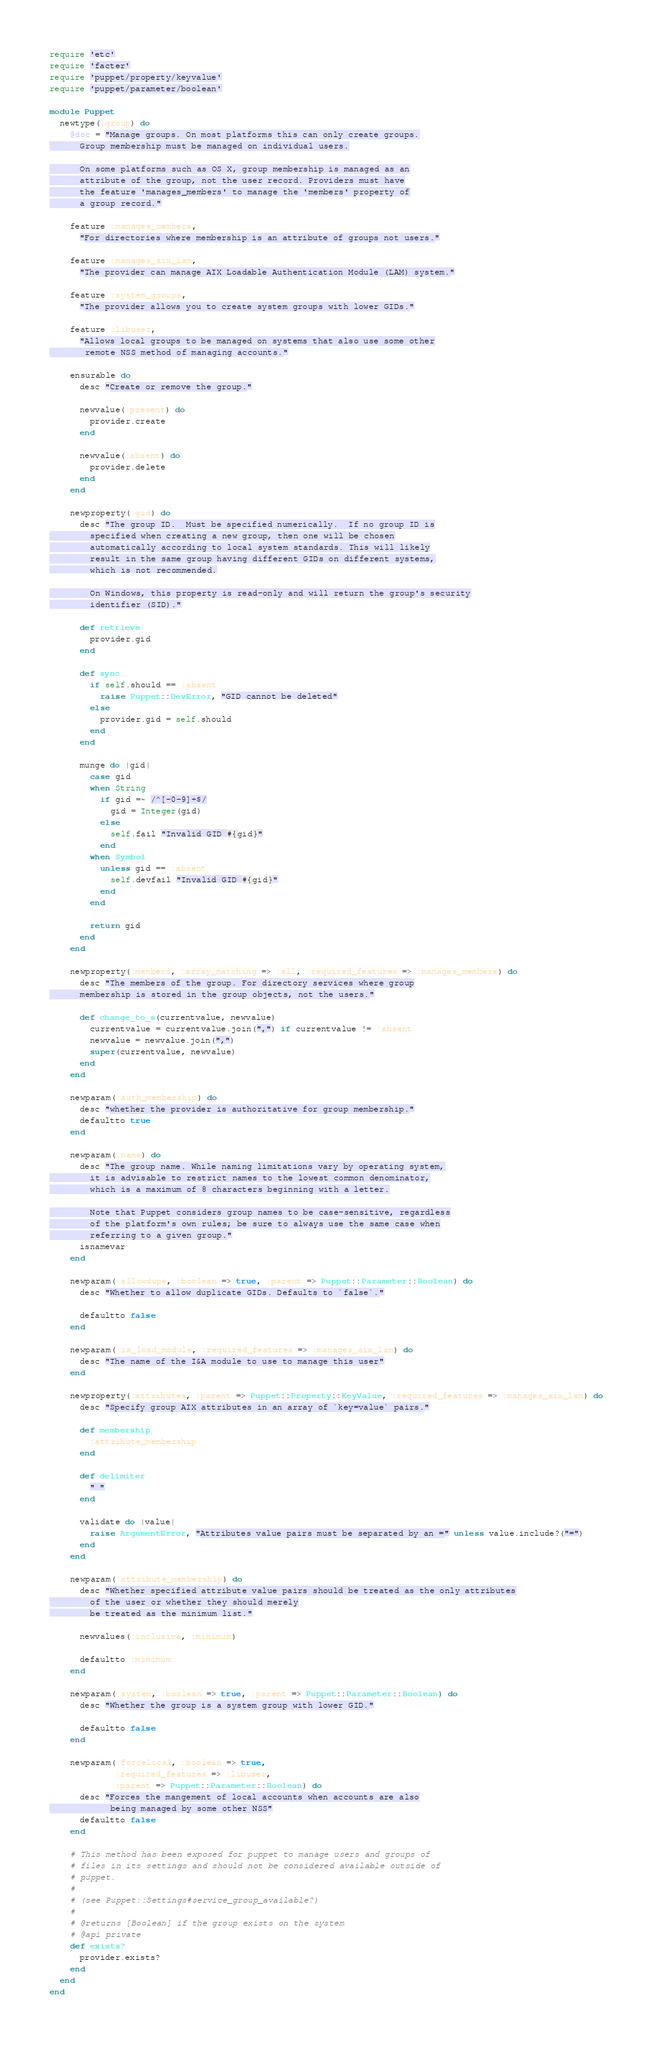Convert code to text. <code><loc_0><loc_0><loc_500><loc_500><_Ruby_>require 'etc'
require 'facter'
require 'puppet/property/keyvalue'
require 'puppet/parameter/boolean'

module Puppet
  newtype(:group) do
    @doc = "Manage groups. On most platforms this can only create groups.
      Group membership must be managed on individual users.

      On some platforms such as OS X, group membership is managed as an
      attribute of the group, not the user record. Providers must have
      the feature 'manages_members' to manage the 'members' property of
      a group record."

    feature :manages_members,
      "For directories where membership is an attribute of groups not users."

    feature :manages_aix_lam,
      "The provider can manage AIX Loadable Authentication Module (LAM) system."

    feature :system_groups,
      "The provider allows you to create system groups with lower GIDs."

    feature :libuser,
      "Allows local groups to be managed on systems that also use some other
       remote NSS method of managing accounts."

    ensurable do
      desc "Create or remove the group."

      newvalue(:present) do
        provider.create
      end

      newvalue(:absent) do
        provider.delete
      end
    end

    newproperty(:gid) do
      desc "The group ID.  Must be specified numerically.  If no group ID is
        specified when creating a new group, then one will be chosen
        automatically according to local system standards. This will likely
        result in the same group having different GIDs on different systems,
        which is not recommended.

        On Windows, this property is read-only and will return the group's security
        identifier (SID)."

      def retrieve
        provider.gid
      end

      def sync
        if self.should == :absent
          raise Puppet::DevError, "GID cannot be deleted"
        else
          provider.gid = self.should
        end
      end

      munge do |gid|
        case gid
        when String
          if gid =~ /^[-0-9]+$/
            gid = Integer(gid)
          else
            self.fail "Invalid GID #{gid}"
          end
        when Symbol
          unless gid == :absent
            self.devfail "Invalid GID #{gid}"
          end
        end

        return gid
      end
    end

    newproperty(:members, :array_matching => :all, :required_features => :manages_members) do
      desc "The members of the group. For directory services where group
      membership is stored in the group objects, not the users."

      def change_to_s(currentvalue, newvalue)
        currentvalue = currentvalue.join(",") if currentvalue != :absent
        newvalue = newvalue.join(",")
        super(currentvalue, newvalue)
      end
    end

    newparam(:auth_membership) do
      desc "whether the provider is authoritative for group membership."
      defaultto true
    end

    newparam(:name) do
      desc "The group name. While naming limitations vary by operating system,
        it is advisable to restrict names to the lowest common denominator,
        which is a maximum of 8 characters beginning with a letter.

        Note that Puppet considers group names to be case-sensitive, regardless
        of the platform's own rules; be sure to always use the same case when
        referring to a given group."
      isnamevar
    end

    newparam(:allowdupe, :boolean => true, :parent => Puppet::Parameter::Boolean) do
      desc "Whether to allow duplicate GIDs. Defaults to `false`."

      defaultto false
    end

    newparam(:ia_load_module, :required_features => :manages_aix_lam) do
      desc "The name of the I&A module to use to manage this user"
    end

    newproperty(:attributes, :parent => Puppet::Property::KeyValue, :required_features => :manages_aix_lam) do
      desc "Specify group AIX attributes in an array of `key=value` pairs."

      def membership
        :attribute_membership
      end

      def delimiter
        " "
      end

      validate do |value|
        raise ArgumentError, "Attributes value pairs must be separated by an =" unless value.include?("=")
      end
    end

    newparam(:attribute_membership) do
      desc "Whether specified attribute value pairs should be treated as the only attributes
        of the user or whether they should merely
        be treated as the minimum list."

      newvalues(:inclusive, :minimum)

      defaultto :minimum
    end

    newparam(:system, :boolean => true, :parent => Puppet::Parameter::Boolean) do
      desc "Whether the group is a system group with lower GID."

      defaultto false
    end

    newparam(:forcelocal, :boolean => true,
             :required_features => :libuser,
             :parent => Puppet::Parameter::Boolean) do
      desc "Forces the mangement of local accounts when accounts are also
            being managed by some other NSS"
      defaultto false
    end

    # This method has been exposed for puppet to manage users and groups of
    # files in its settings and should not be considered available outside of
    # puppet.
    #
    # (see Puppet::Settings#service_group_available?)
    #
    # @returns [Boolean] if the group exists on the system
    # @api private
    def exists?
      provider.exists?
    end
  end
end
</code> 